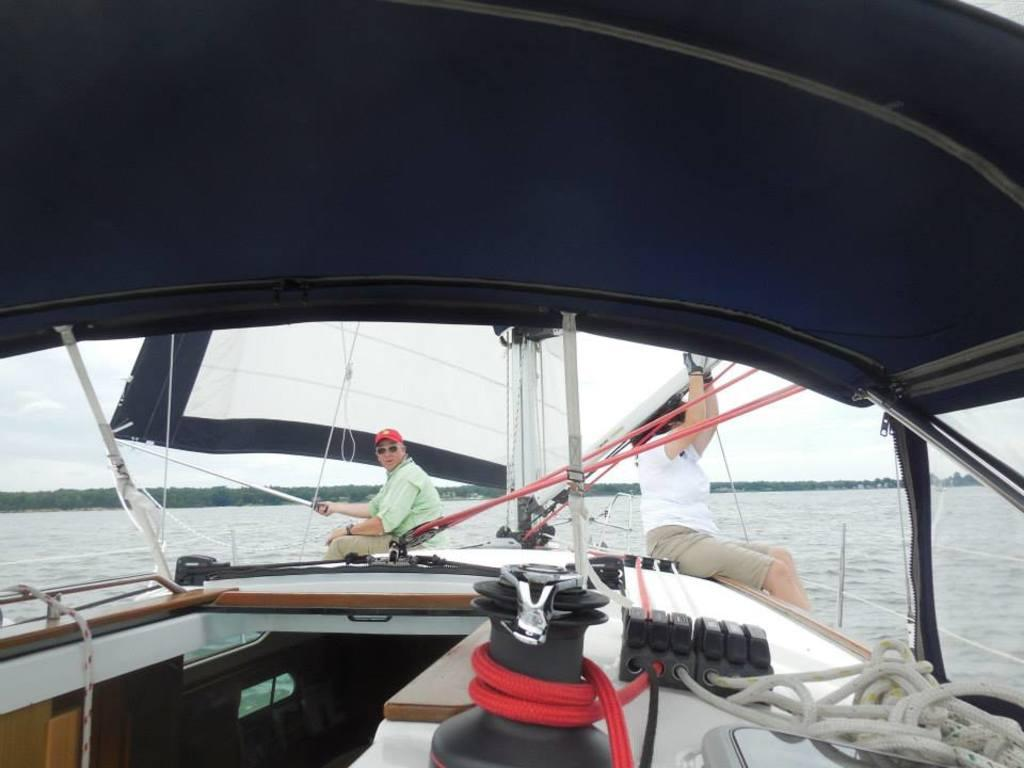How many people are in the image? There are two persons in the image. What are the persons doing in the image? The persons are sitting on a boat. Where is the boat located in the image? The boat is on the water. What can be seen in the background of the image? There are trees and the sky visible in the image. What type of juice is being served on the roof in the image? There is no juice or roof present in the image; it features two persons sitting on a boat on the water. 